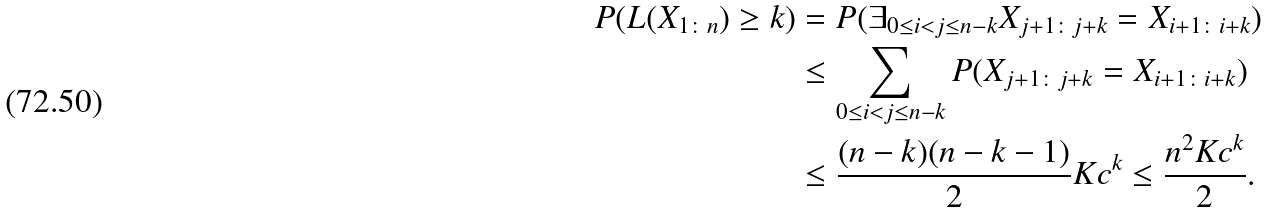Convert formula to latex. <formula><loc_0><loc_0><loc_500><loc_500>P ( L ( X _ { 1 \colon n } ) \geq k ) & = P ( \exists _ { 0 \leq i < j \leq n - k } X _ { j + 1 \colon j + k } = X _ { i + 1 \colon i + k } ) \\ & \leq \sum _ { 0 \leq i < j \leq n - k } P ( X _ { j + 1 \colon j + k } = X _ { i + 1 \colon i + k } ) \\ & \leq \frac { ( n - k ) ( n - k - 1 ) } { 2 } K c ^ { k } \leq \frac { n ^ { 2 } K c ^ { k } } { 2 } .</formula> 